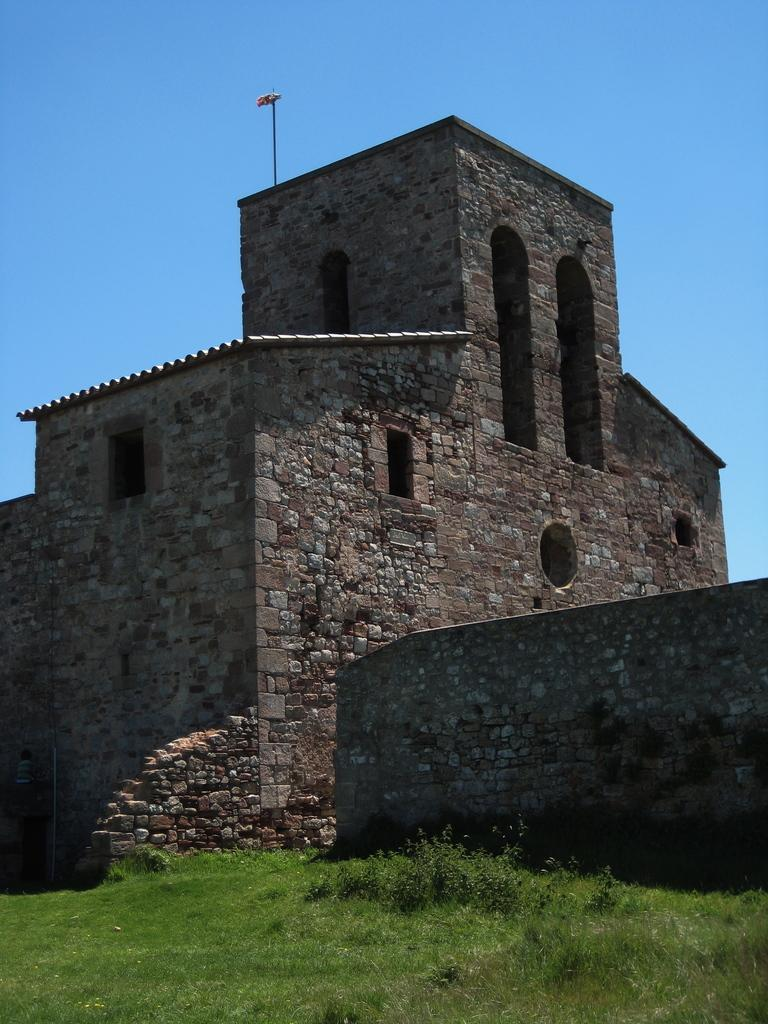What structure is the main subject of the image? There is a building in the image. What is located on the roof of the building? There is a flag on the roof of the building. What type of vegetation is visible at the bottom of the image? Green grass is visible at the bottom of the image. What is present on the right side of the image? There is a wall on the right side of the image. What is visible at the top of the image? The sky is visible at the top of the image. What type of engine can be seen powering the building in the image? There is no engine present in the image, as buildings do not have engines. What place is the building located in the image? The image does not provide information about the specific location of the building. 